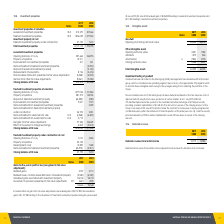According to National Storage Reit's financial document, What determines the recoverable amount of the listed group? based on the fair value less costs of disposal method using the fair value quoted on an active market.. The document states: "ble amount of the listed group has been determined based on the fair value less costs of disposal method using the fair value quoted on an active mark..." Also, How much did NSR had stapled securities quoted on the Australian Securities Exchange as at 1 July 2019? According to the financial document, 773,343,956. The relevant text states: "d on an active market. As at 1 July 2019, NSR had 773,343,956 stapled securities quoted on the Australian Securities Exchange at $1.745 per security providing a..." Also, What would be the impact if security price decreased by 2.5%? the market capitalisation would still have been in excess of the carrying amount.. The document states: "note 13). Had the security price decreased by 2.5% the market capitalisation would still have been in excess of the carrying amount. 10.6. Deferred re..." Also, can you calculate: What is the change in Other intangible assets Opening net book value from 2018 to 2019? Based on the calculation: 2,051-1,582, the result is 469 (in thousands). This is based on the information: "Opening net book value 2,051 1,582 Opening net book value 2,051 1,582..." The key data points involved are: 1,582, 2,051. Also, can you calculate: What is the change in Other intangible assets Additions from 2018 to 2019? Based on the calculation: 1,079-864, the result is 215 (in thousands). This is based on the information: "Additions 1,079 864 Additions 1,079 864..." The key data points involved are: 1,079, 864. Also, can you calculate: What is the change in Other intangible assets Amortisation 2018 to 2019? Based on the calculation: 584-395, the result is 189 (in thousands). This is based on the information: "Amortisation 6 (584) (395) Amortisation 6 (584) (395)..." The key data points involved are: 395, 584. 